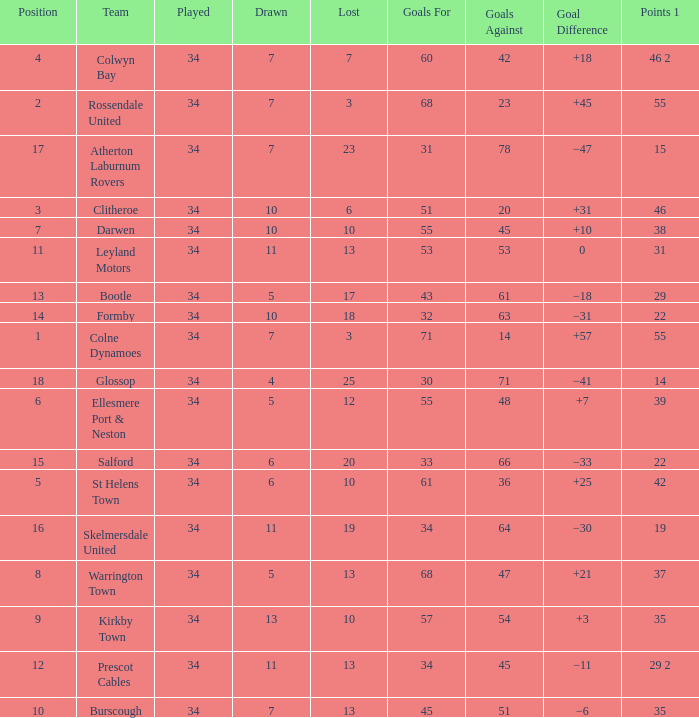Which Position has 47 Goals Against, and a Played larger than 34? None. Would you mind parsing the complete table? {'header': ['Position', 'Team', 'Played', 'Drawn', 'Lost', 'Goals For', 'Goals Against', 'Goal Difference', 'Points 1'], 'rows': [['4', 'Colwyn Bay', '34', '7', '7', '60', '42', '+18', '46 2'], ['2', 'Rossendale United', '34', '7', '3', '68', '23', '+45', '55'], ['17', 'Atherton Laburnum Rovers', '34', '7', '23', '31', '78', '−47', '15'], ['3', 'Clitheroe', '34', '10', '6', '51', '20', '+31', '46'], ['7', 'Darwen', '34', '10', '10', '55', '45', '+10', '38'], ['11', 'Leyland Motors', '34', '11', '13', '53', '53', '0', '31'], ['13', 'Bootle', '34', '5', '17', '43', '61', '−18', '29'], ['14', 'Formby', '34', '10', '18', '32', '63', '−31', '22'], ['1', 'Colne Dynamoes', '34', '7', '3', '71', '14', '+57', '55'], ['18', 'Glossop', '34', '4', '25', '30', '71', '−41', '14'], ['6', 'Ellesmere Port & Neston', '34', '5', '12', '55', '48', '+7', '39'], ['15', 'Salford', '34', '6', '20', '33', '66', '−33', '22'], ['5', 'St Helens Town', '34', '6', '10', '61', '36', '+25', '42'], ['16', 'Skelmersdale United', '34', '11', '19', '34', '64', '−30', '19'], ['8', 'Warrington Town', '34', '5', '13', '68', '47', '+21', '37'], ['9', 'Kirkby Town', '34', '13', '10', '57', '54', '+3', '35'], ['12', 'Prescot Cables', '34', '11', '13', '34', '45', '−11', '29 2'], ['10', 'Burscough', '34', '7', '13', '45', '51', '−6', '35']]} 